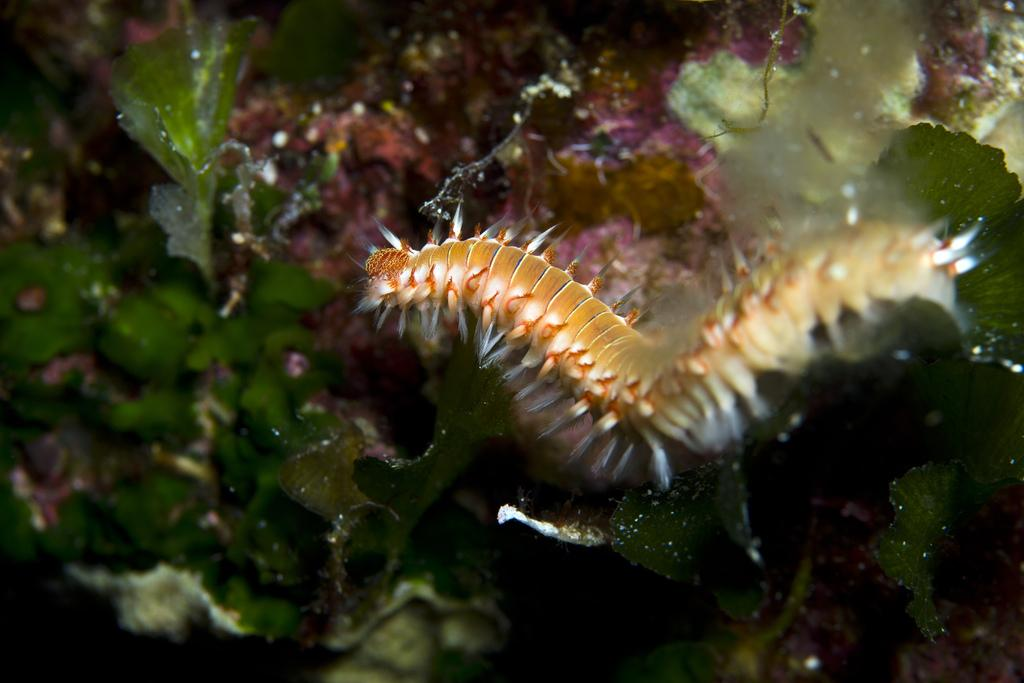What is the main subject of the image? The main subject of the image is a worm. What can be seen in the background of the image? There are leaves in the background of the image. What type of aftermath can be seen in the image? There is no aftermath present in the image; it features a worm and leaves in the background. Can you tell me where the judge is located in the image? There is no judge present in the image. 